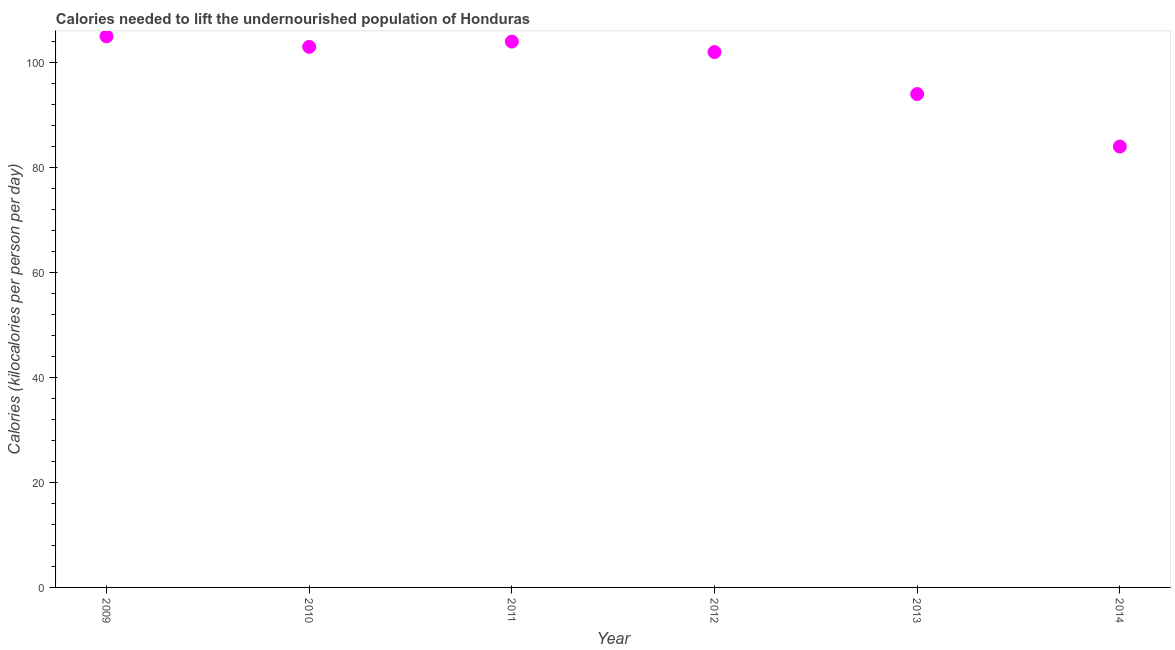What is the depth of food deficit in 2009?
Provide a succinct answer. 105. Across all years, what is the maximum depth of food deficit?
Provide a succinct answer. 105. Across all years, what is the minimum depth of food deficit?
Ensure brevity in your answer.  84. In which year was the depth of food deficit maximum?
Give a very brief answer. 2009. What is the sum of the depth of food deficit?
Make the answer very short. 592. What is the difference between the depth of food deficit in 2012 and 2014?
Your answer should be very brief. 18. What is the average depth of food deficit per year?
Make the answer very short. 98.67. What is the median depth of food deficit?
Provide a short and direct response. 102.5. In how many years, is the depth of food deficit greater than 72 kilocalories?
Offer a terse response. 6. What is the ratio of the depth of food deficit in 2010 to that in 2013?
Your response must be concise. 1.1. Is the difference between the depth of food deficit in 2010 and 2011 greater than the difference between any two years?
Ensure brevity in your answer.  No. What is the difference between the highest and the second highest depth of food deficit?
Make the answer very short. 1. Is the sum of the depth of food deficit in 2013 and 2014 greater than the maximum depth of food deficit across all years?
Your answer should be compact. Yes. What is the difference between the highest and the lowest depth of food deficit?
Make the answer very short. 21. In how many years, is the depth of food deficit greater than the average depth of food deficit taken over all years?
Provide a succinct answer. 4. Does the depth of food deficit monotonically increase over the years?
Offer a terse response. No. How many dotlines are there?
Ensure brevity in your answer.  1. What is the difference between two consecutive major ticks on the Y-axis?
Keep it short and to the point. 20. What is the title of the graph?
Your response must be concise. Calories needed to lift the undernourished population of Honduras. What is the label or title of the Y-axis?
Provide a succinct answer. Calories (kilocalories per person per day). What is the Calories (kilocalories per person per day) in 2009?
Provide a succinct answer. 105. What is the Calories (kilocalories per person per day) in 2010?
Offer a terse response. 103. What is the Calories (kilocalories per person per day) in 2011?
Offer a very short reply. 104. What is the Calories (kilocalories per person per day) in 2012?
Provide a short and direct response. 102. What is the Calories (kilocalories per person per day) in 2013?
Make the answer very short. 94. What is the Calories (kilocalories per person per day) in 2014?
Your answer should be very brief. 84. What is the difference between the Calories (kilocalories per person per day) in 2009 and 2010?
Provide a succinct answer. 2. What is the difference between the Calories (kilocalories per person per day) in 2009 and 2012?
Make the answer very short. 3. What is the difference between the Calories (kilocalories per person per day) in 2009 and 2013?
Ensure brevity in your answer.  11. What is the difference between the Calories (kilocalories per person per day) in 2009 and 2014?
Give a very brief answer. 21. What is the difference between the Calories (kilocalories per person per day) in 2010 and 2013?
Offer a terse response. 9. What is the difference between the Calories (kilocalories per person per day) in 2011 and 2012?
Your answer should be very brief. 2. What is the difference between the Calories (kilocalories per person per day) in 2012 and 2013?
Give a very brief answer. 8. What is the ratio of the Calories (kilocalories per person per day) in 2009 to that in 2010?
Offer a very short reply. 1.02. What is the ratio of the Calories (kilocalories per person per day) in 2009 to that in 2012?
Offer a terse response. 1.03. What is the ratio of the Calories (kilocalories per person per day) in 2009 to that in 2013?
Your answer should be very brief. 1.12. What is the ratio of the Calories (kilocalories per person per day) in 2010 to that in 2011?
Provide a short and direct response. 0.99. What is the ratio of the Calories (kilocalories per person per day) in 2010 to that in 2013?
Your answer should be very brief. 1.1. What is the ratio of the Calories (kilocalories per person per day) in 2010 to that in 2014?
Give a very brief answer. 1.23. What is the ratio of the Calories (kilocalories per person per day) in 2011 to that in 2013?
Your answer should be very brief. 1.11. What is the ratio of the Calories (kilocalories per person per day) in 2011 to that in 2014?
Your answer should be very brief. 1.24. What is the ratio of the Calories (kilocalories per person per day) in 2012 to that in 2013?
Keep it short and to the point. 1.08. What is the ratio of the Calories (kilocalories per person per day) in 2012 to that in 2014?
Give a very brief answer. 1.21. What is the ratio of the Calories (kilocalories per person per day) in 2013 to that in 2014?
Give a very brief answer. 1.12. 